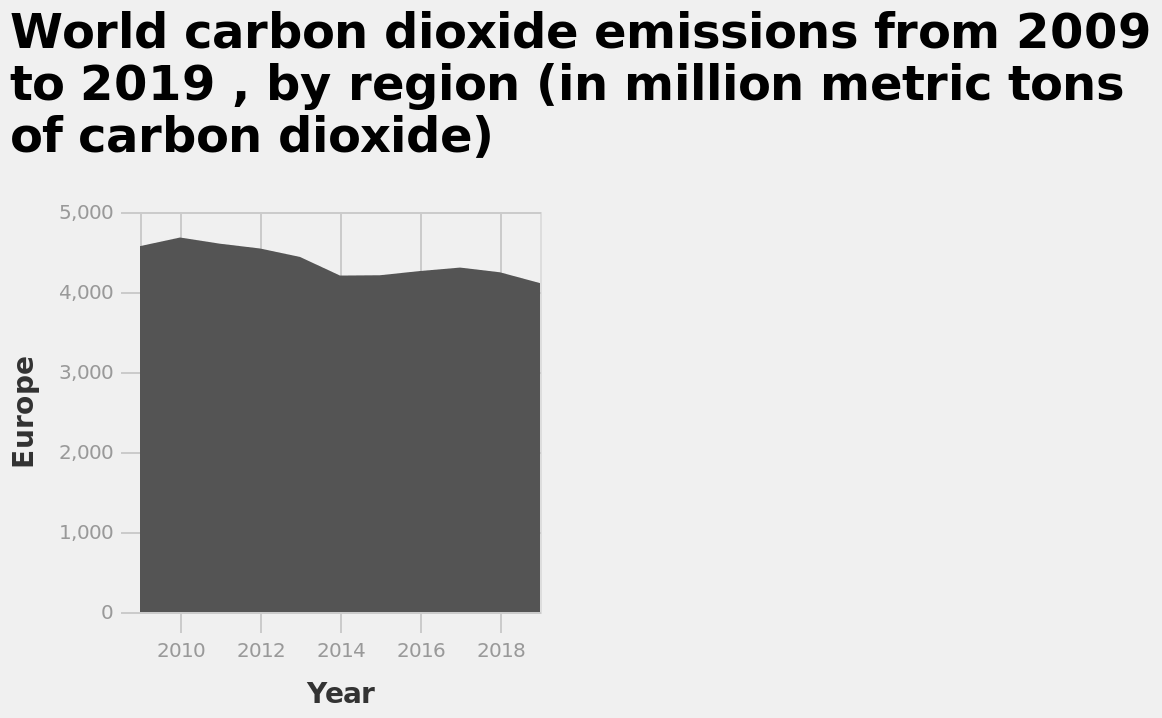<image>
Has there been a decline or increase in carbon dioxide emissions in Europe from 2009 to 2019? There has been a slow decline in carbon dioxide emissions in Europe from 4500 million metric tons in 2009 to 4000 million metric tons in 2019. What was the amount of carbon dioxide emissions in Europe in 2019? The amount of carbon dioxide emissions in Europe in 2019 was 4000 million metric tons. 